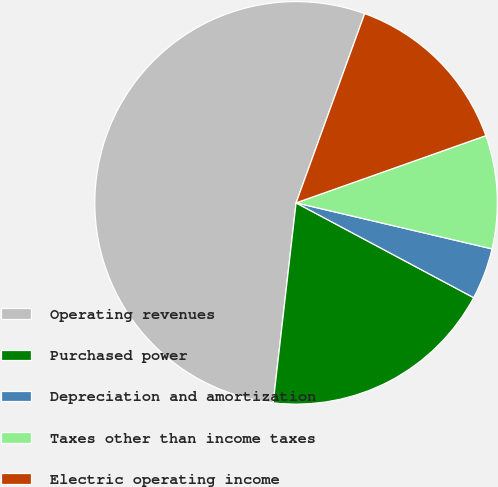Convert chart. <chart><loc_0><loc_0><loc_500><loc_500><pie_chart><fcel>Operating revenues<fcel>Purchased power<fcel>Depreciation and amortization<fcel>Taxes other than income taxes<fcel>Electric operating income<nl><fcel>53.72%<fcel>19.01%<fcel>4.13%<fcel>9.09%<fcel>14.05%<nl></chart> 